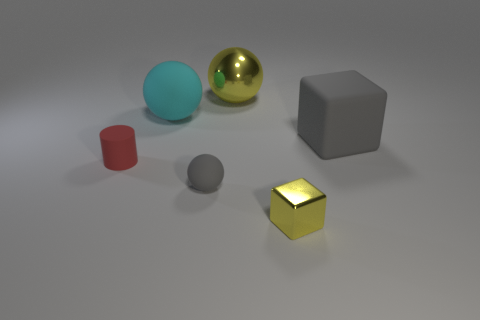Are there any gray spheres made of the same material as the red cylinder?
Make the answer very short. Yes. What size is the cube that is the same color as the large metal object?
Provide a short and direct response. Small. How many blocks are either gray rubber objects or cyan metal things?
Make the answer very short. 1. What size is the gray ball?
Ensure brevity in your answer.  Small. There is a big cyan rubber ball; how many big cyan spheres are behind it?
Your answer should be very brief. 0. There is a yellow metal object that is in front of the yellow sphere that is to the right of the small matte cylinder; how big is it?
Provide a succinct answer. Small. Does the large thing that is in front of the large cyan thing have the same shape as the small gray matte object that is in front of the large block?
Your answer should be very brief. No. What is the shape of the yellow metal object to the right of the yellow metal thing that is behind the big matte ball?
Your response must be concise. Cube. There is a thing that is both on the left side of the tiny gray thing and behind the tiny red matte cylinder; what size is it?
Your response must be concise. Large. There is a tiny metallic thing; is it the same shape as the tiny object that is to the left of the cyan thing?
Offer a very short reply. No. 